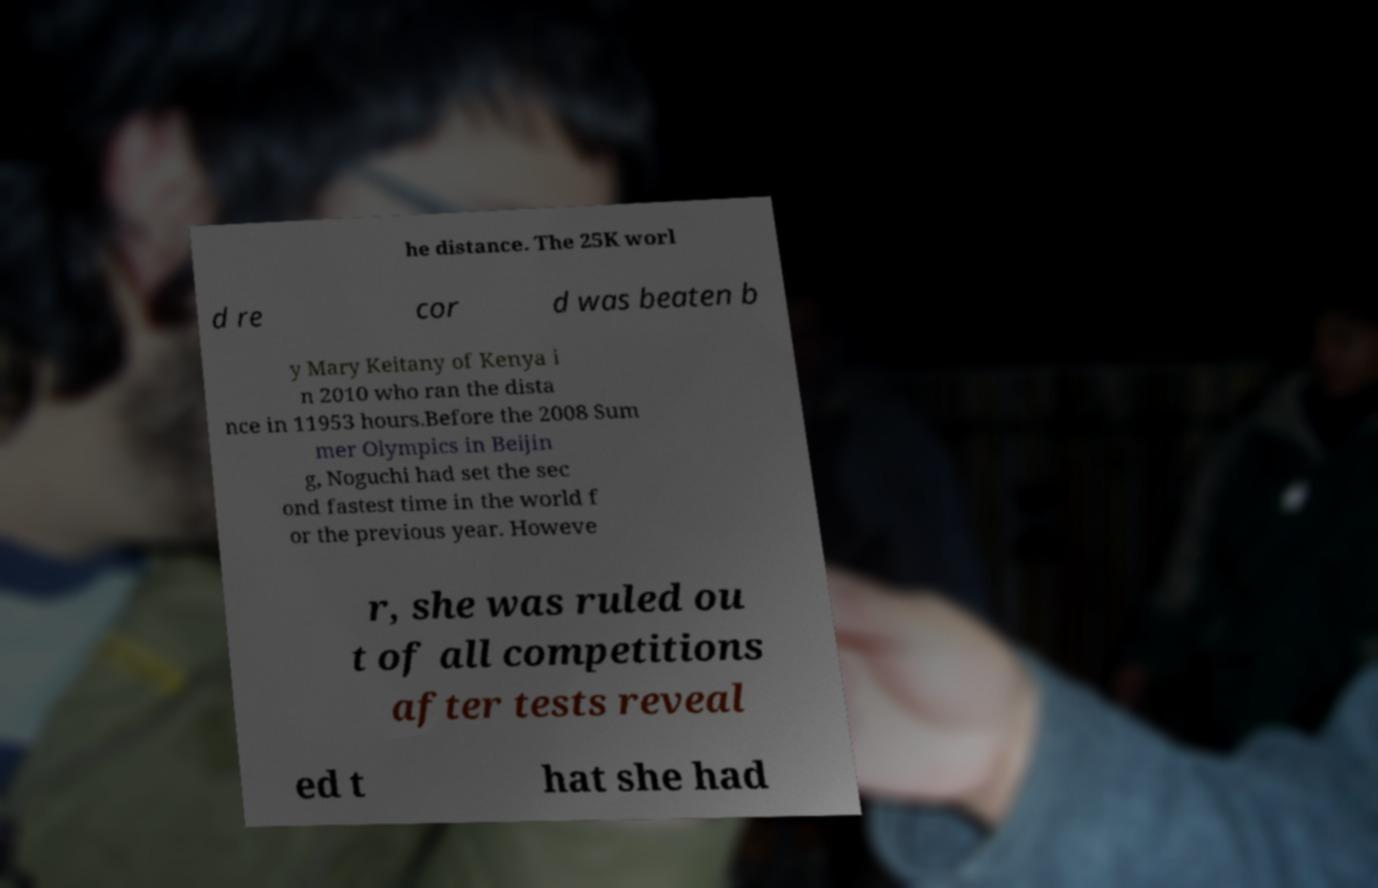Could you assist in decoding the text presented in this image and type it out clearly? he distance. The 25K worl d re cor d was beaten b y Mary Keitany of Kenya i n 2010 who ran the dista nce in 11953 hours.Before the 2008 Sum mer Olympics in Beijin g, Noguchi had set the sec ond fastest time in the world f or the previous year. Howeve r, she was ruled ou t of all competitions after tests reveal ed t hat she had 